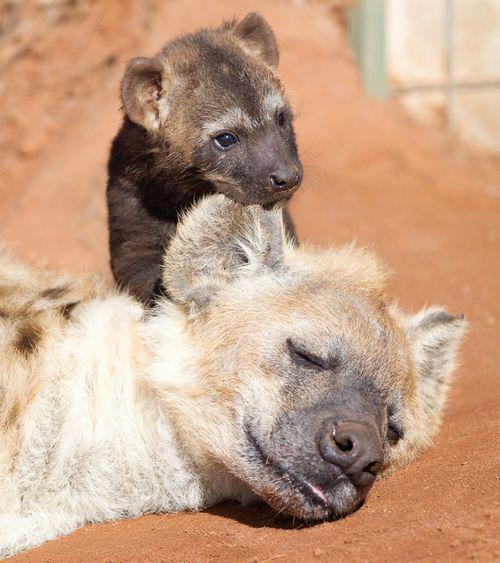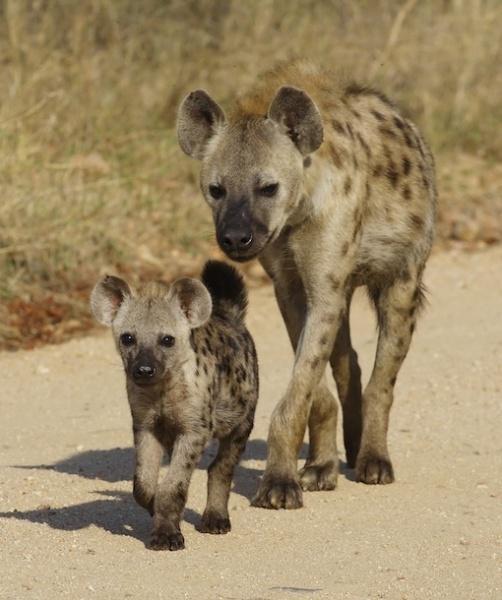The first image is the image on the left, the second image is the image on the right. Analyze the images presented: Is the assertion "One image includes a dark hyena pup and an adult hyena, and shows their heads one above the other." valid? Answer yes or no. Yes. The first image is the image on the left, the second image is the image on the right. Considering the images on both sides, is "The right image contains exactly two hyenas." valid? Answer yes or no. Yes. 